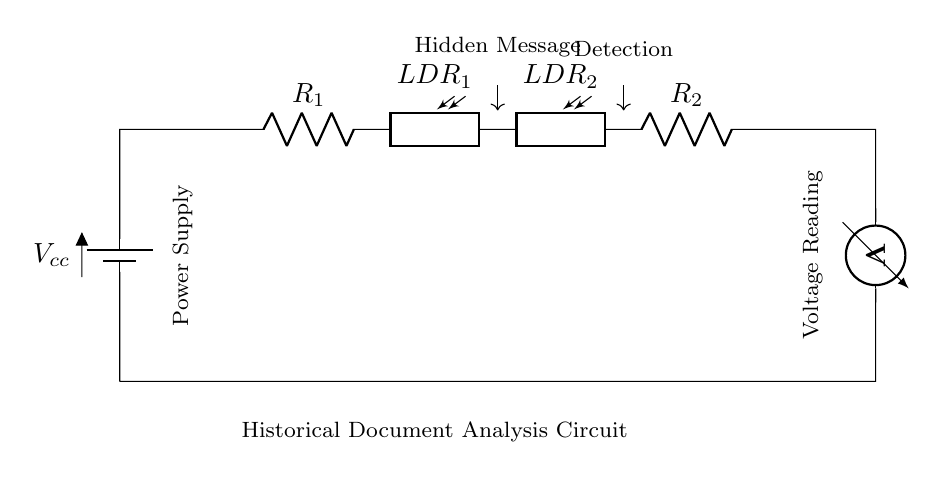What is the type of circuit depicted? The circuit is a series circuit, which can be identified by the single pathway for current to flow through all components sequentially from the power supply to the voltage meter.
Answer: series circuit How many photoresistors are in the circuit? There are two photoresistors in the circuit, as indicated by the labeled components LDR_1 and LDR_2.
Answer: two What does the voltmeter measure? The voltmeter measures the voltage across the last resistor R_2 in the series, providing the potential difference in the circuit for analysis.
Answer: voltage What component is used for detecting hidden messages? The photoresistors LDR_1 and LDR_2 are used for detecting hidden messages, as they change resistance in response to light that might reveal the message.
Answer: LDR What is the role of R_1 and R_2 in this circuit? R_1 and R_2 serve as current limiters in the circuit, ensuring that the flow of current does not exceed safe levels for the photoresistors and other components.
Answer: current limiters What is the purpose of the power supply in the circuit? The power supply provides the necessary voltage for the circuit to operate, enabling the flow of current required for the detection process.
Answer: provides voltage 